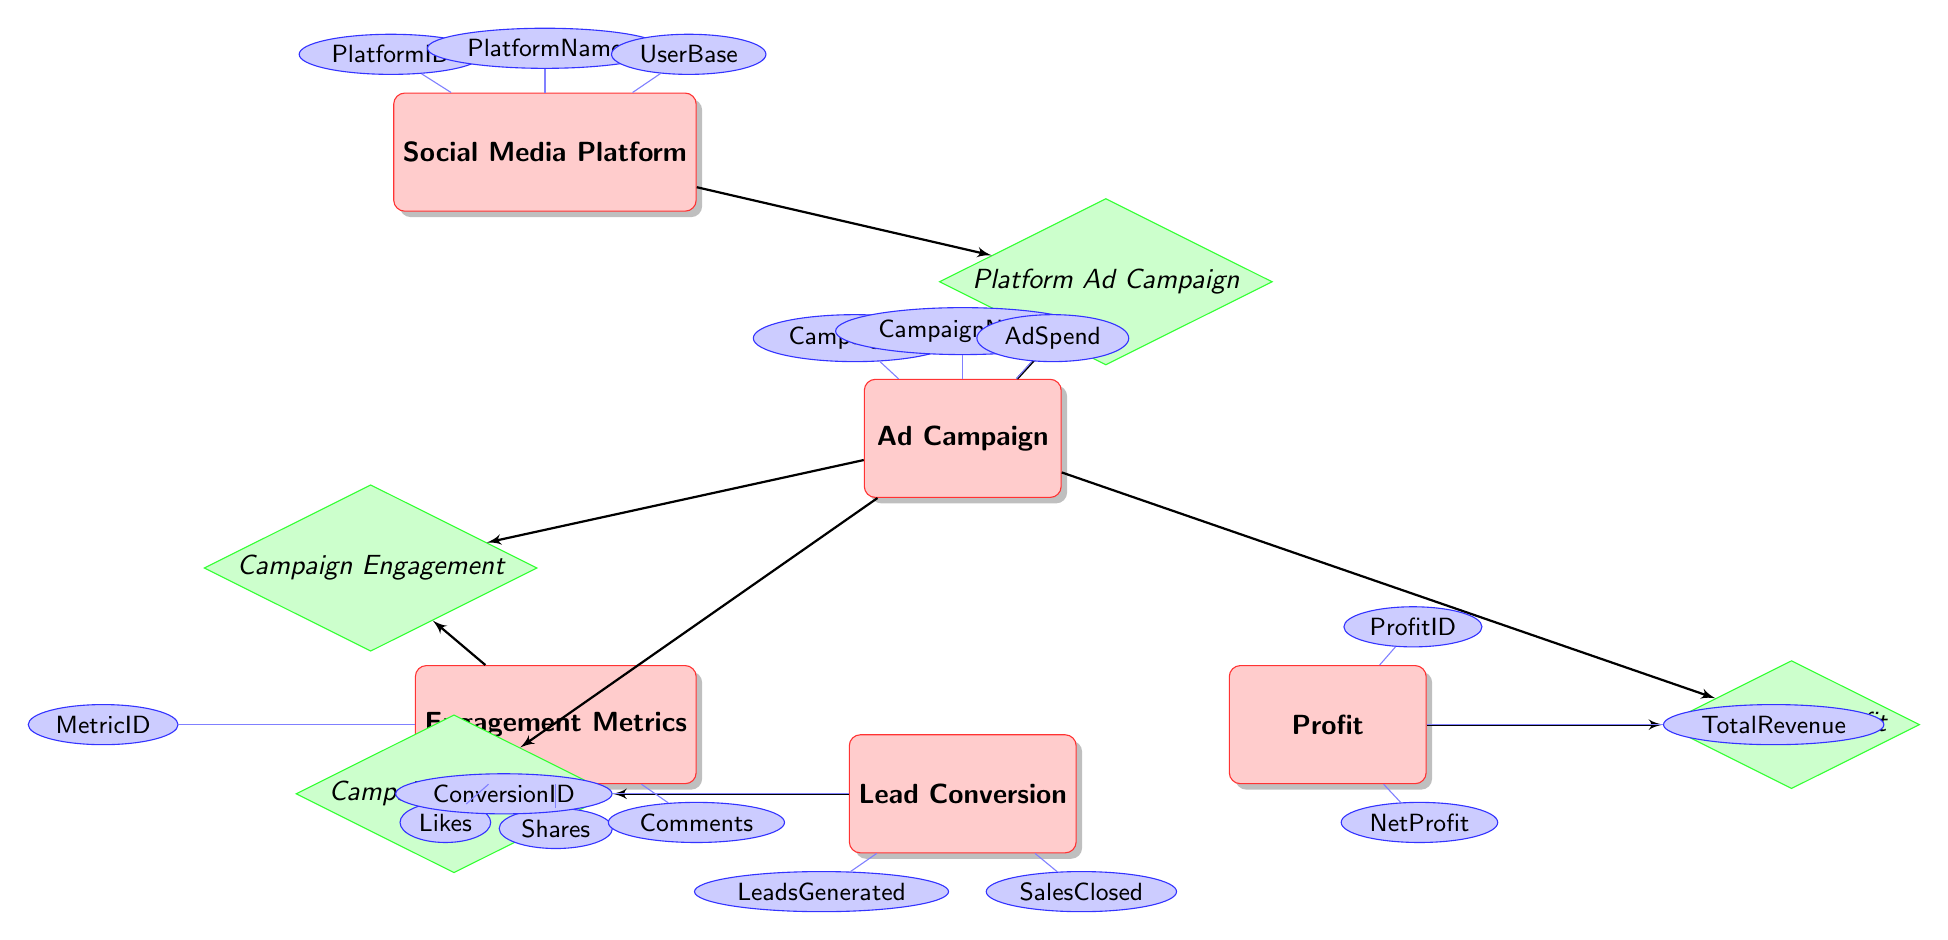What entity has the attribute "UserBase"? In the diagram, the "UserBase" attribute is connected to the "Social Media Platform" entity. The attributes are visually associated with their respective entities, and "UserBase" is specifically listed under the "Social Media Platform".
Answer: Social Media Platform How many attributes does the "Ad Campaign" entity have? The "Ad Campaign" entity has three attributes: "CampaignID", "CampaignName", and "AdSpend". This can be counted by looking at the attributes specifically connected to the "Ad Campaign" node.
Answer: 3 What is the relationship between "Ad Campaign" and "Lead Conversion"? The relationship between "Ad Campaign" and "Lead Conversion" is named "Campaign Conversion". This can be found by following the connecting line from the "Ad Campaign" node to the "Lead Conversion" node, with the relationship diamond labeled accordingly.
Answer: Campaign Conversion What is the total number of entities in the diagram? The total number of entities in the diagram can be counted by listing the mentioned entities: "SocialMediaPlatform", "AdCampaign", "EngagementMetrics", "LeadConversion", and "Profit". This gives us a total count of five entities.
Answer: 5 Which entity is linked to "Engagement Metrics"? The "Ad Campaign" entity is linked to "Engagement Metrics" through the "Campaign Engagement" relationship. The connection can be traced back to the "Ad Campaign" node, which points to "Engagement Metrics" via the relevant relationship.
Answer: Ad Campaign What is the primary identifier for the "Profit" entity? The primary identifier for the "Profit" entity is "ProfitID". This can be identified by examining the attributes listed under the "Profit" entity in the diagram.
Answer: ProfitID How many engagement metrics are identified in the "Engagement Metrics" entity? The "Engagement Metrics" entity identifies four engagement metrics: "MetricID", "Likes", "Shares", and "Comments". This total is determined by counting the attributes associated with the "Engagement Metrics" node.
Answer: 4 What is the relationship between "Ad Campaign" and "Profit"? The relationship between "Ad Campaign" and "Profit" is called "Campaign Profit". This can be identified by following the line that connects "Ad Campaign" to the "Profit" entity, leading to the labeled relationship diamond.
Answer: Campaign Profit Which entity includes the "LeadsGenerated" attribute? The "Lead Conversion" entity includes the "LeadsGenerated" attribute. This can be recognized by looking at the attributes linked to that specific entity within the diagram.
Answer: Lead Conversion 